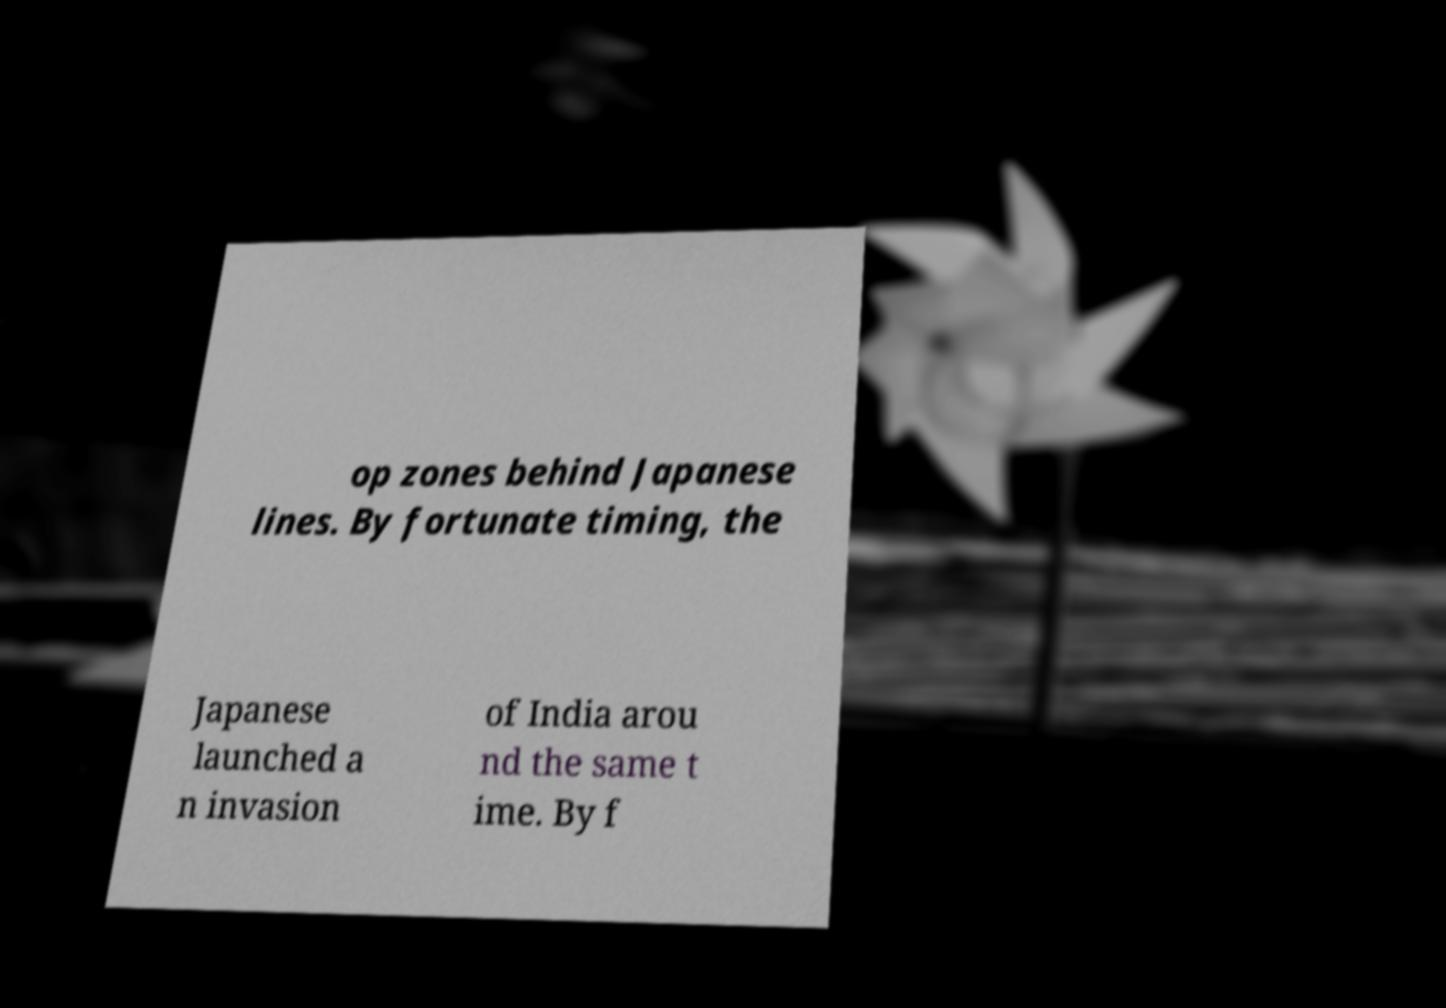Can you read and provide the text displayed in the image?This photo seems to have some interesting text. Can you extract and type it out for me? op zones behind Japanese lines. By fortunate timing, the Japanese launched a n invasion of India arou nd the same t ime. By f 